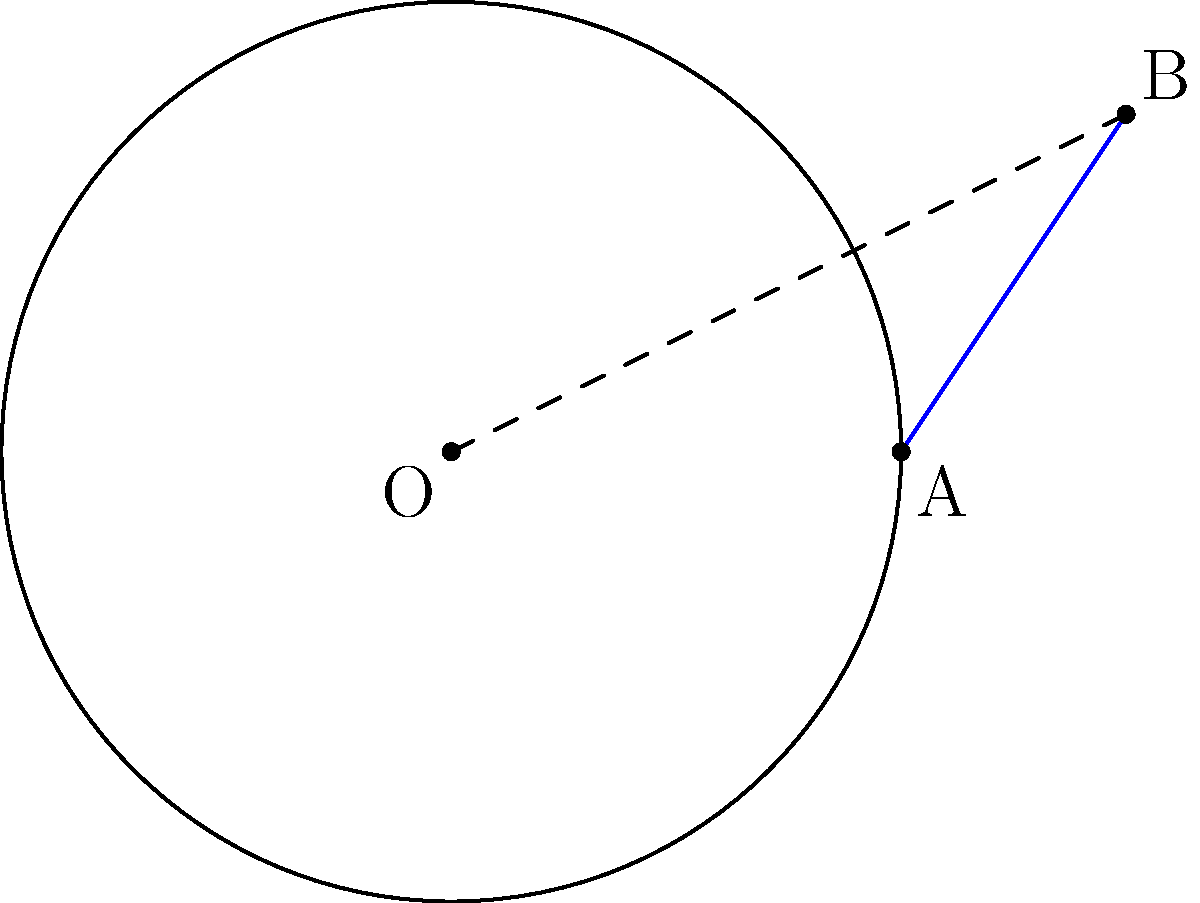In the diagram, a circle with center O and radius 4 units is shown. Point A lies on the circle, and point B is external to the circle. If the length of the tangent line AB is x units, find the length of OB. Let's approach this step-by-step:

1) In a circle, a tangent line is perpendicular to the radius drawn to the point of tangency. Therefore, OAB forms a right-angled triangle with the right angle at A.

2) We can use the Pythagorean theorem in this right-angled triangle:

   $OB^2 = OA^2 + AB^2$

3) We know that:
   - OA is the radius of the circle, which is 4 units
   - AB is the tangent line, with length x units

4) Substituting these into the Pythagorean theorem:

   $OB^2 = 4^2 + x^2$

5) Simplify:

   $OB^2 = 16 + x^2$

6) Therefore, the length of OB is:

   $OB = \sqrt{16 + x^2}$

This expression gives us the length of OB in terms of the tangent length x.
Answer: $\sqrt{16 + x^2}$ 